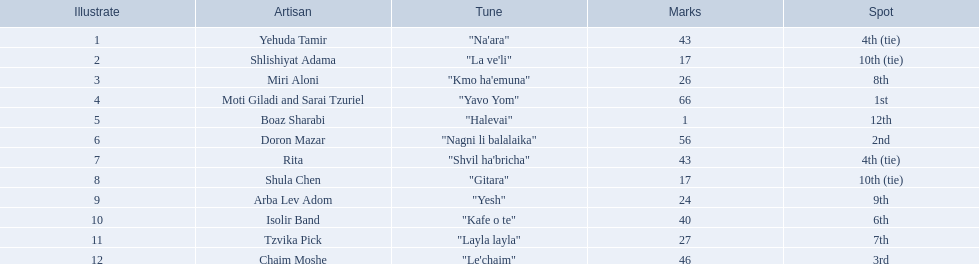How many artists are there? Yehuda Tamir, Shlishiyat Adama, Miri Aloni, Moti Giladi and Sarai Tzuriel, Boaz Sharabi, Doron Mazar, Rita, Shula Chen, Arba Lev Adom, Isolir Band, Tzvika Pick, Chaim Moshe. What is the least amount of points awarded? 1. Who was the artist awarded those points? Boaz Sharabi. 